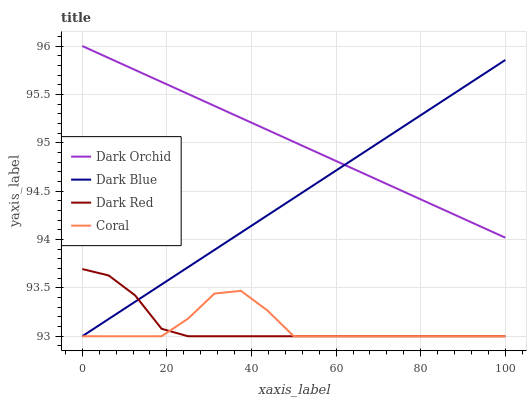Does Coral have the minimum area under the curve?
Answer yes or no. Yes. Does Dark Orchid have the maximum area under the curve?
Answer yes or no. Yes. Does Dark Orchid have the minimum area under the curve?
Answer yes or no. No. Does Coral have the maximum area under the curve?
Answer yes or no. No. Is Dark Orchid the smoothest?
Answer yes or no. Yes. Is Coral the roughest?
Answer yes or no. Yes. Is Coral the smoothest?
Answer yes or no. No. Is Dark Orchid the roughest?
Answer yes or no. No. Does Dark Blue have the lowest value?
Answer yes or no. Yes. Does Dark Orchid have the lowest value?
Answer yes or no. No. Does Dark Orchid have the highest value?
Answer yes or no. Yes. Does Coral have the highest value?
Answer yes or no. No. Is Coral less than Dark Orchid?
Answer yes or no. Yes. Is Dark Orchid greater than Dark Red?
Answer yes or no. Yes. Does Dark Blue intersect Dark Orchid?
Answer yes or no. Yes. Is Dark Blue less than Dark Orchid?
Answer yes or no. No. Is Dark Blue greater than Dark Orchid?
Answer yes or no. No. Does Coral intersect Dark Orchid?
Answer yes or no. No. 